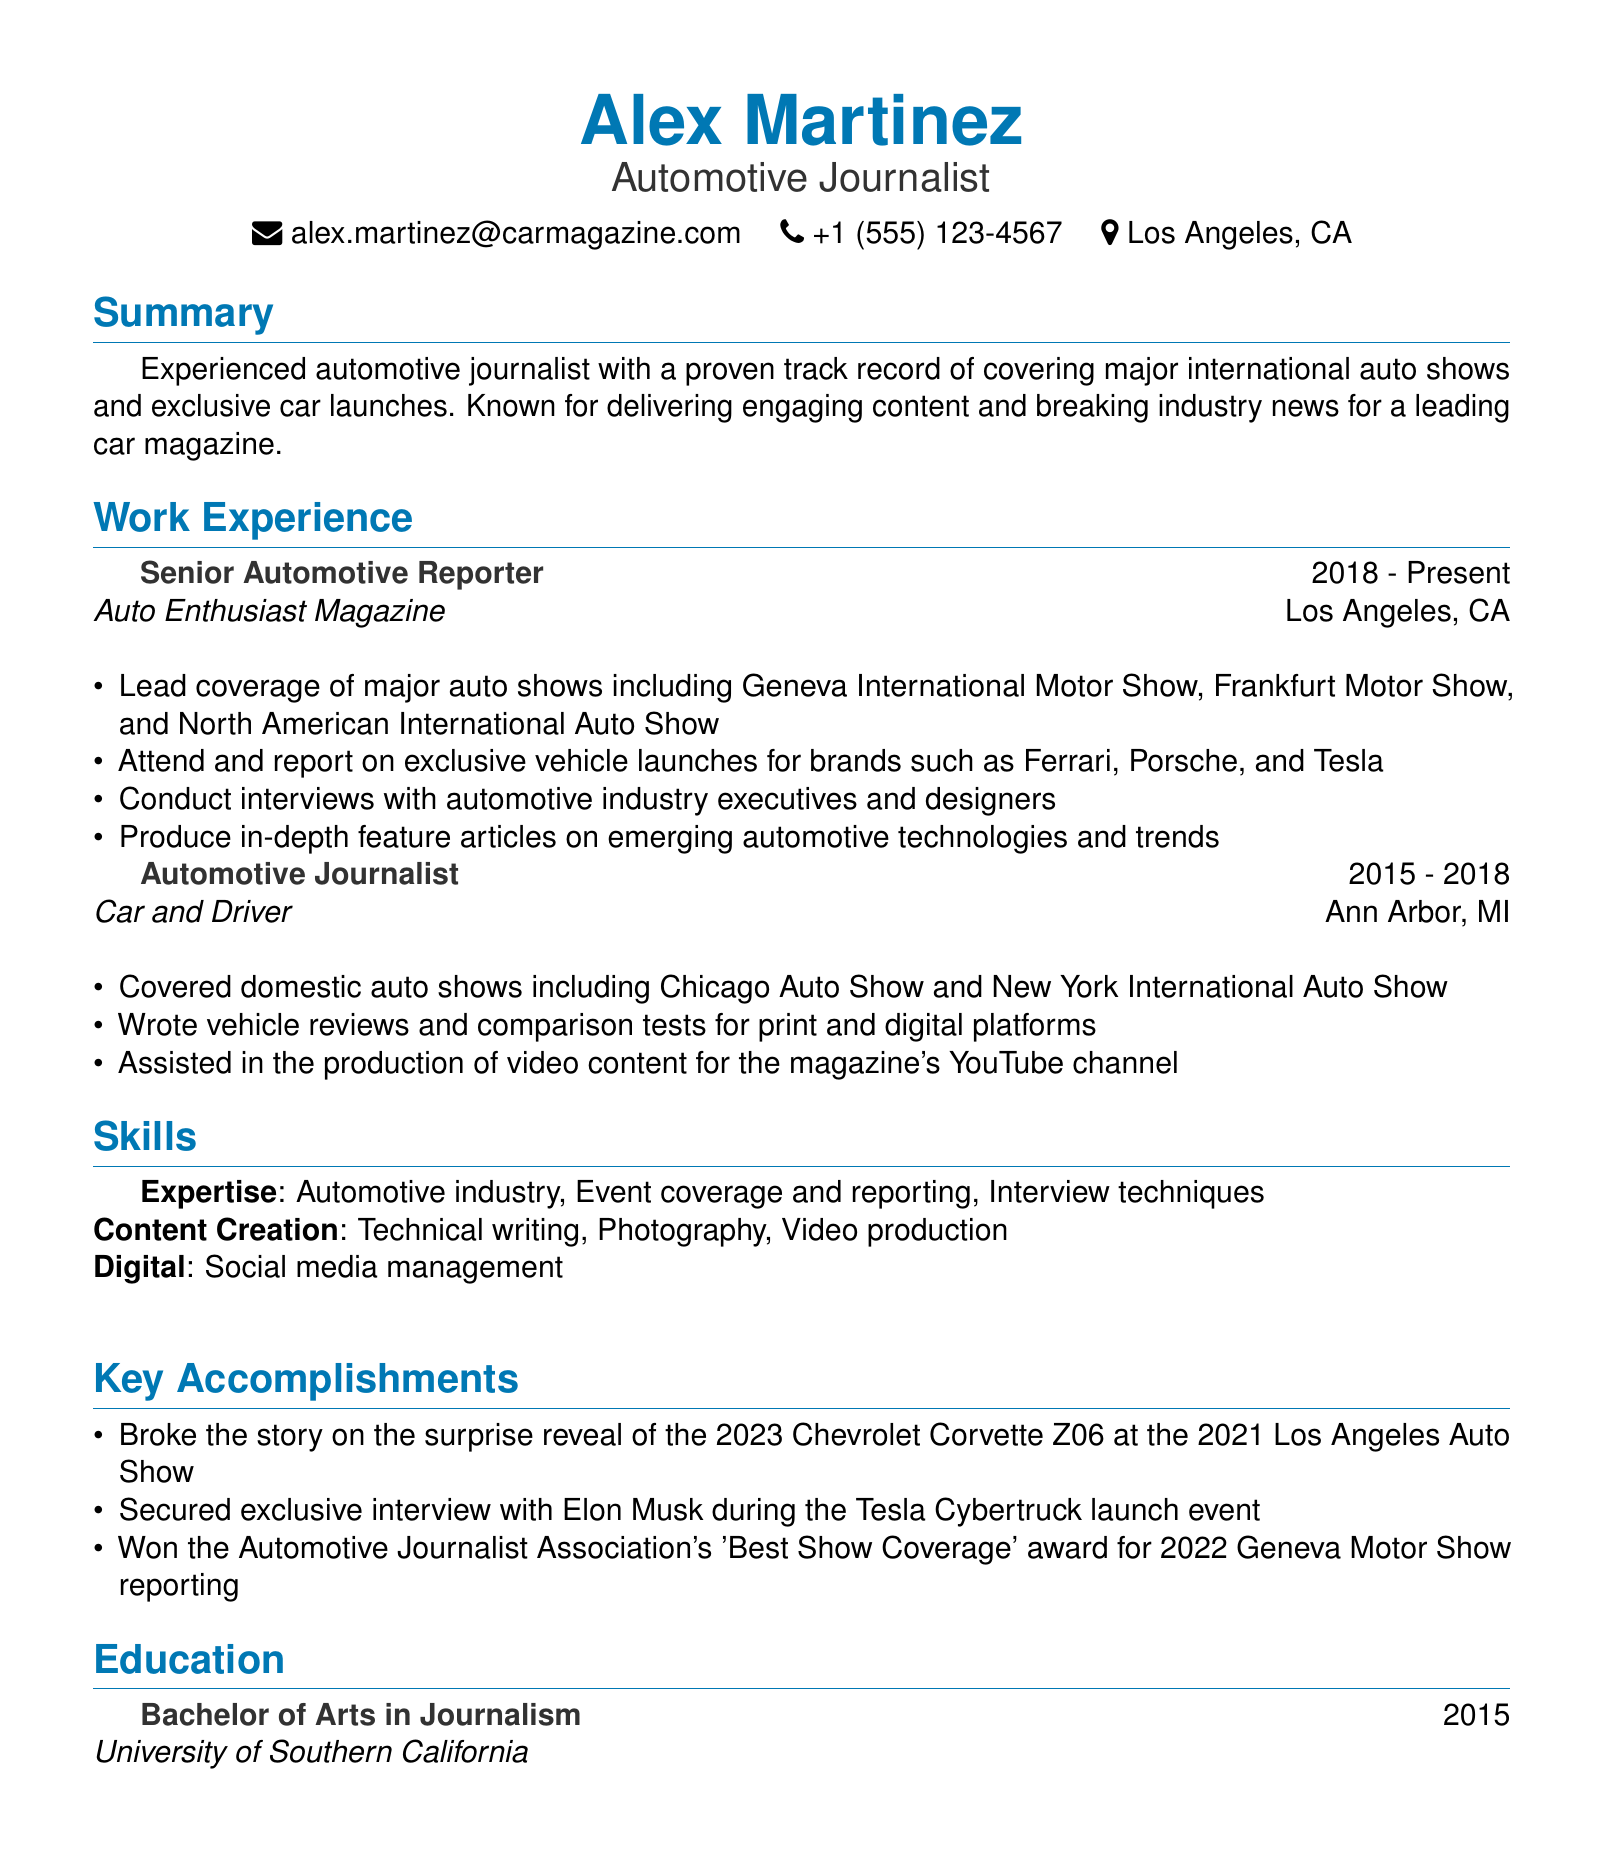what is the name of the journalist? The document clearly states that the journalist's name is Alex Martinez.
Answer: Alex Martinez what is the location of the current position? The document indicates that the Senior Automotive Reporter position is located in Los Angeles, CA.
Answer: Los Angeles, CA how many years of experience does the journalist have? By calculating the years from the provided work experiences (2015 to present), the total number is 8 years.
Answer: 8 years what award did Alex win in 2022? The key accomplishments section mentions that Alex won the 'Best Show Coverage' award for the 2022 Geneva Motor Show.
Answer: Best Show Coverage which company did Alex work for before Auto Enthusiast Magazine? The work experience list shows that Alex worked for Car and Driver prior to Auto Enthusiast Magazine.
Answer: Car and Driver what degree did Alex earn? The education section specifies that Alex earned a Bachelor of Arts in Journalism.
Answer: Bachelor of Arts in Journalism which major auto shows did Alex cover in the current role? The responsibilities in the current position include covering the Geneva International Motor Show, Frankfurt Motor Show, and North American International Auto Show.
Answer: Geneva International Motor Show, Frankfurt Motor Show, North American International Auto Show who did Alex secure an exclusive interview with? The key accomplishments highlight that Alex secured an exclusive interview with Elon Musk.
Answer: Elon Musk 